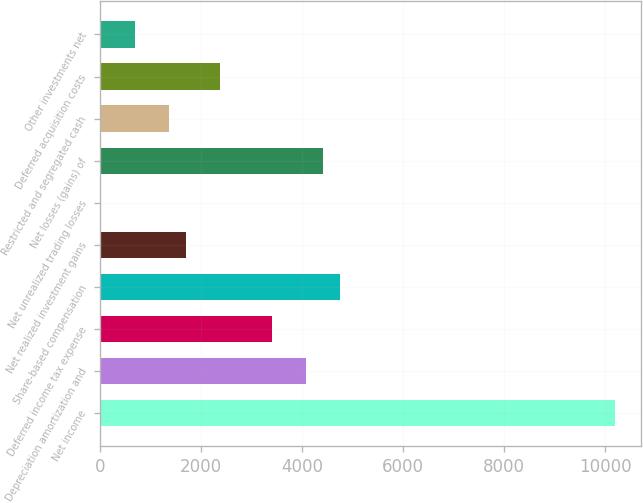Convert chart. <chart><loc_0><loc_0><loc_500><loc_500><bar_chart><fcel>Net income<fcel>Depreciation amortization and<fcel>Deferred income tax expense<fcel>Share-based compensation<fcel>Net realized investment gains<fcel>Net unrealized trading losses<fcel>Net losses (gains) of<fcel>Restricted and segregated cash<fcel>Deferred acquisition costs<fcel>Other investments net<nl><fcel>10195<fcel>4078.6<fcel>3399<fcel>4758.2<fcel>1700<fcel>1<fcel>4418.4<fcel>1360.2<fcel>2379.6<fcel>680.6<nl></chart> 